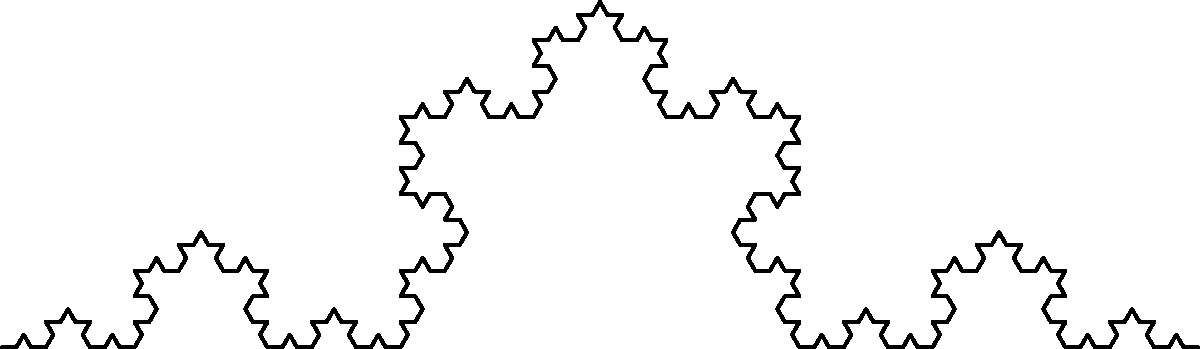In the black-and-white fractal image above, which represents a Koch snowflake curve, how does the total length of the curve change with each iteration? Express your answer in terms of the original line segment's length $L$. To understand how the length of the Koch snowflake curve changes with each iteration, let's follow these steps:

1. Start with a line segment of length $L$.

2. In each iteration, we replace the middle third of each line segment with two segments that form an equilateral triangle with the removed segment.

3. This means that for each segment of length $x$, we replace it with 4 segments of length $x/3$.

4. Let's calculate the length for each iteration:
   - Initial length: $L$
   - After 1st iteration: $L * (4/3)$
   - After 2nd iteration: $L * (4/3)^2$
   - After 3rd iteration: $L * (4/3)^3$

5. We can see a pattern forming. After $n$ iterations, the length will be:

   $L_n = L * (4/3)^n$

6. This is a geometric sequence with a common ratio of $4/3$.

7. As $n$ approaches infinity, the length of the curve approaches infinity, despite being contained within a finite area.

This fractal property of infinite length within a bounded area creates a poetic tension between the finite and the infinite, much like how a photograph captures an infinite moment in a finite frame.
Answer: $L * (4/3)^n$ 